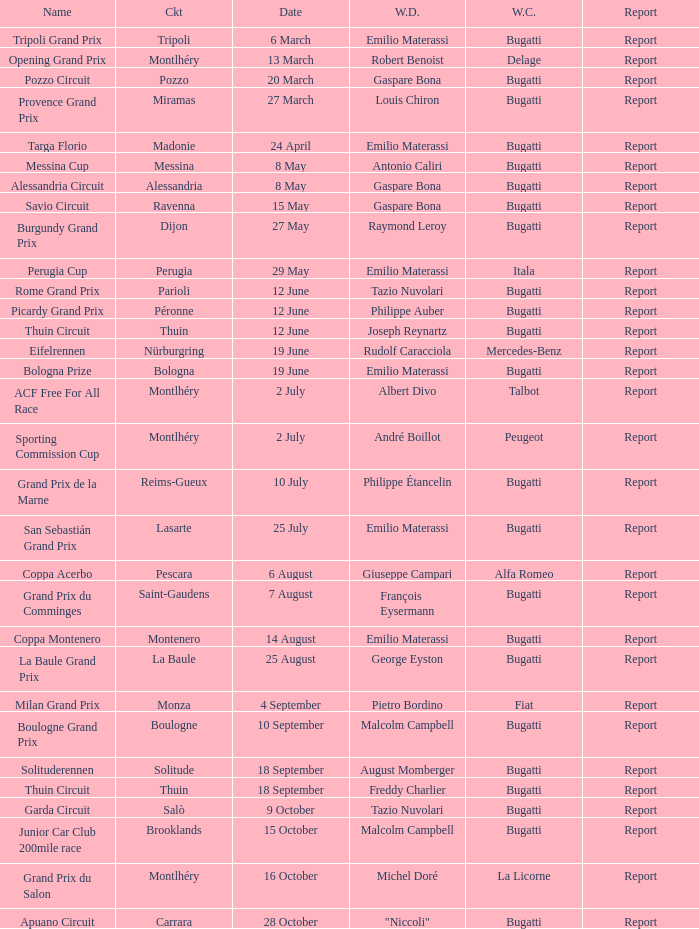Who was the winning constructor at the circuit of parioli? Bugatti. 